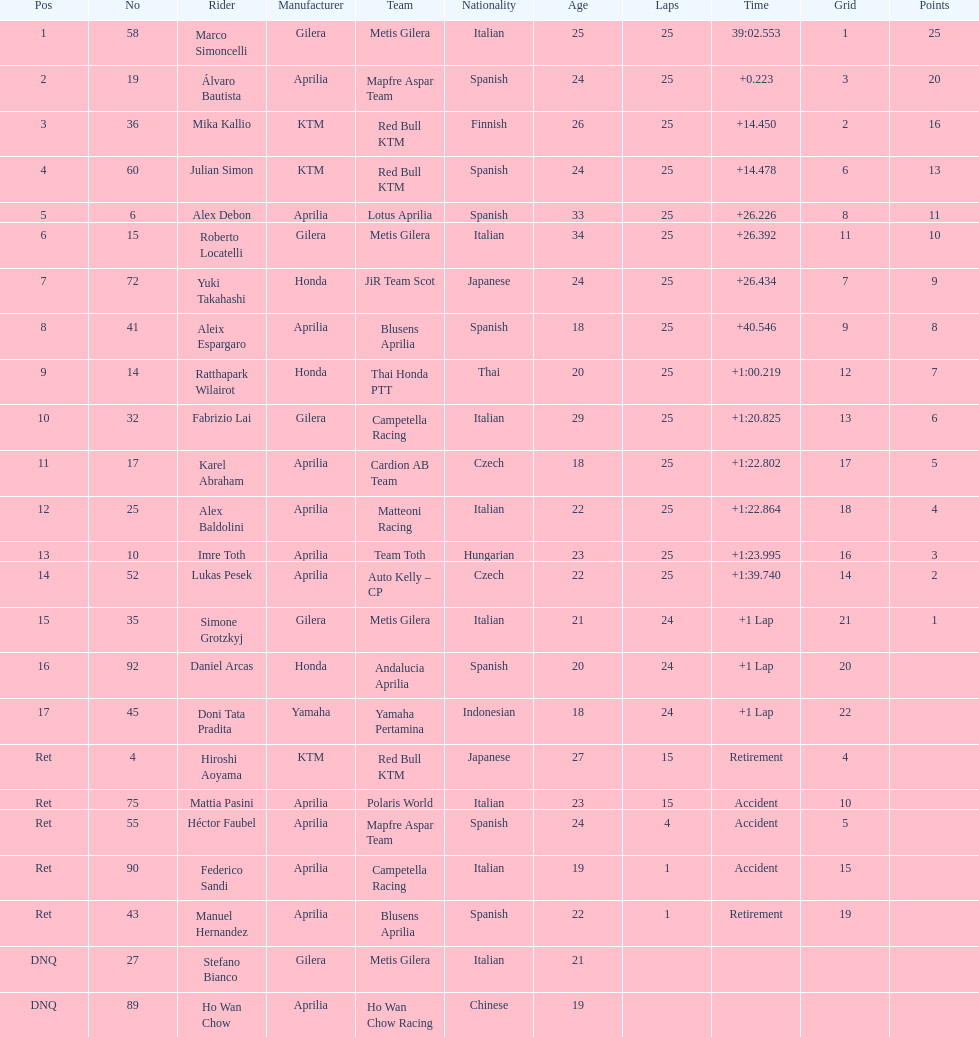The ensuing racer from italy other than the triumphant marco simoncelli was Roberto Locatelli. 